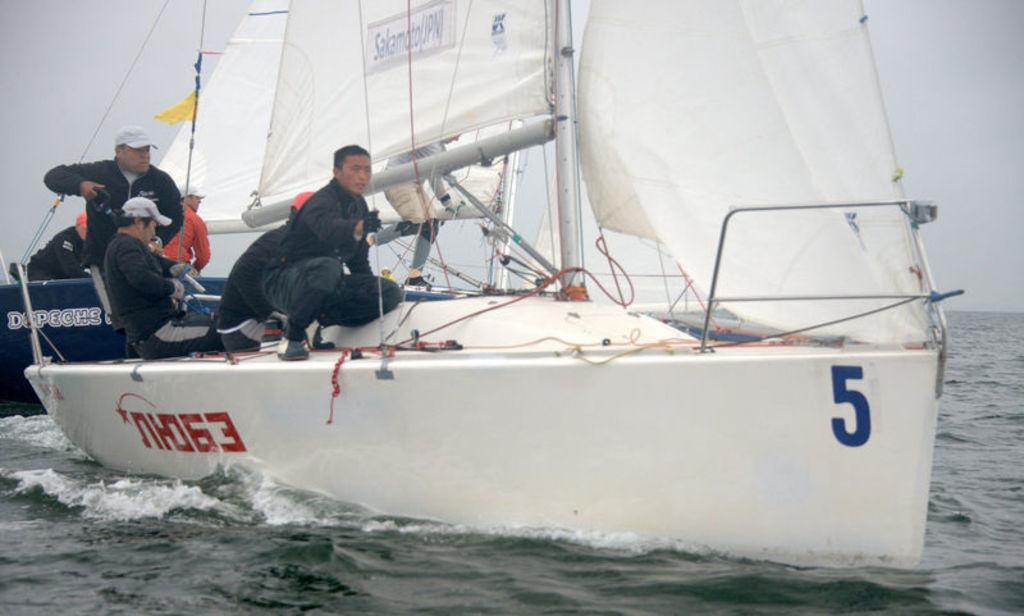What type of vehicles are in the image? There are boats in the image. Who or what is present in the image besides the boats? There are people in the image. Where are the boats located? The boats are on water. What can be seen in the background of the image? The sky is visible in the background of the image. How many legs does the boat have in the image? Boats do not have legs; they are floating on water. What suggestion is being made by the creator of the image? The image does not contain any text or context to suggest a message or suggestion from the creator. 